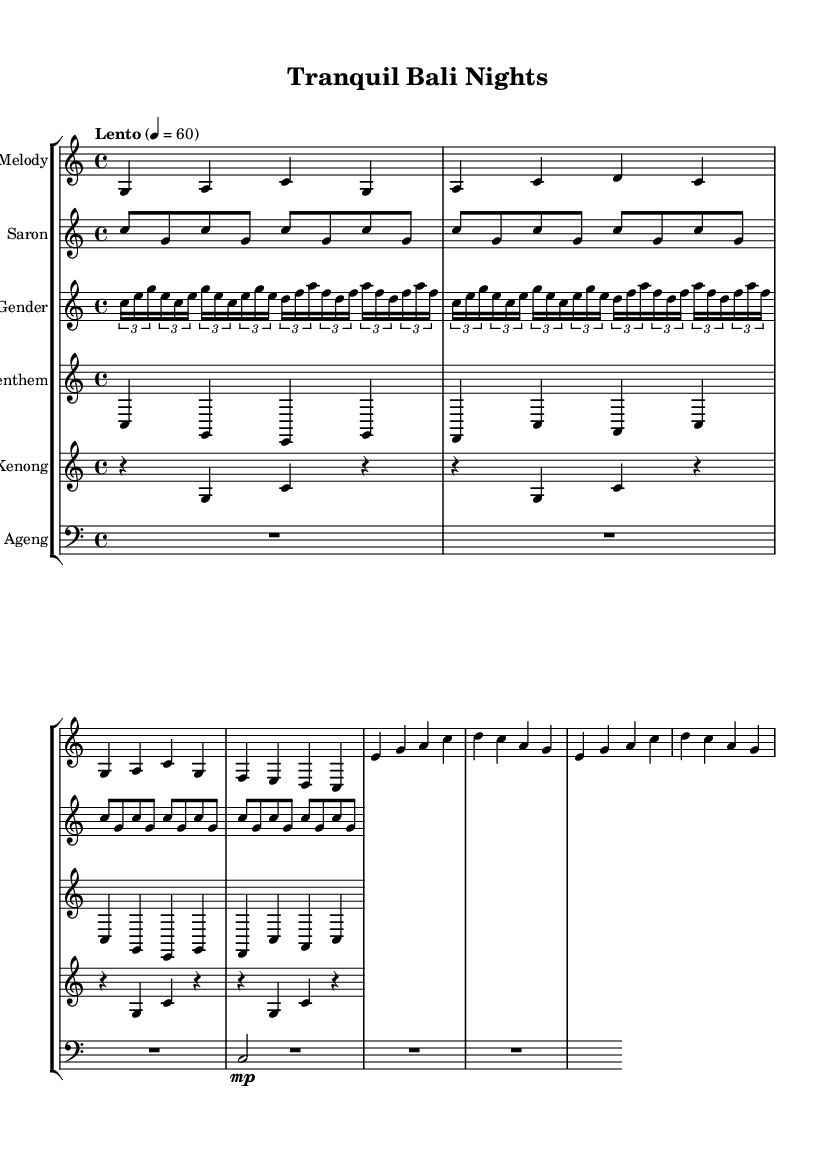What is the key signature of this music? The key signature is indicated in the global section of the code, which specifies C major. C major has no sharps or flats, which can be visually confirmed by looking for the key signature at the beginning of the staff.
Answer: C major What is the time signature of this music? The time signature is mentioned in the global section of the code, indicating a 4/4 time signature. This can be confirmed by finding the "time" command in the sheet music code and observing the 4/4 notation, suggesting four beats per measure.
Answer: 4/4 What is the tempo marking for this piece? The tempo marking is found in the global section of the code, indicating "Lento" at a speed of 60 beats per minute. This tempo marking guides the performer on the speed at which to play the piece.
Answer: Lento 4 = 60 How many measures are in the melody section? The melody section consists of two distinct melodic phrases as noted in the music code; looking closely, we see that each phrase consists of four measures, totaling eight measures when combined.
Answer: 8 Which instrument plays long sustained notes? The Gong Ageng is the instrument that plays long sustained notes, typically represented by the R1*3 notation in the code indicating a whole rest, followed by a quarter note playing the root note for emphasis, which aligns with traditional gamelan usage.
Answer: Gong Ageng What is a unique characteristic of Indonesian gamelan music in this sheet? A unique characteristic is the use of layered textures with multiple interweaving parts, which is consistent with the gamelan style. This can be observed in the various parts such as Saron, Gender, and Slenthem, each contributing distinct rhythmic and melodic patterns that create a harmonious and rich sound.
Answer: Layered textures 